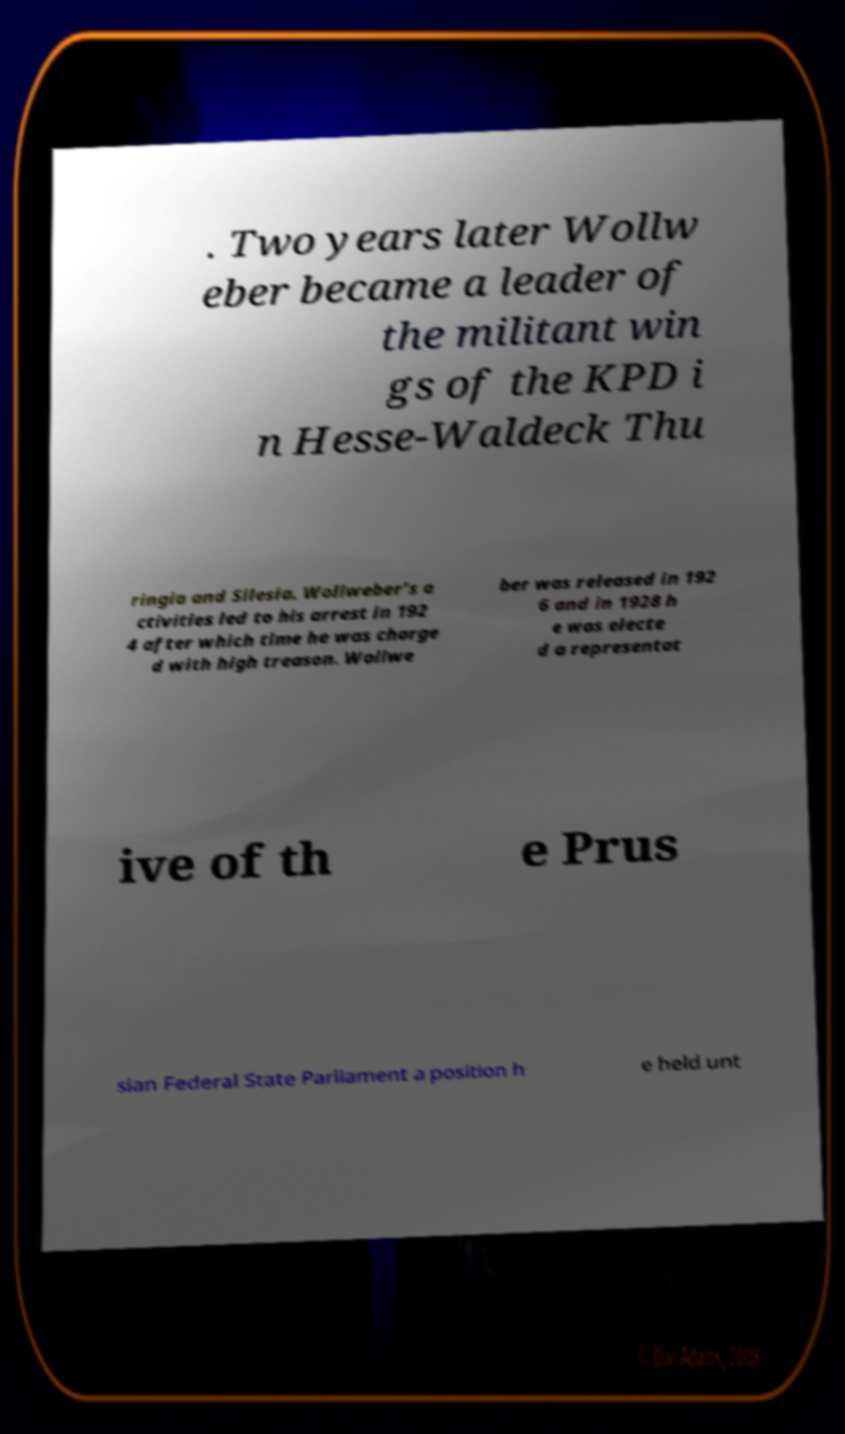Please read and relay the text visible in this image. What does it say? . Two years later Wollw eber became a leader of the militant win gs of the KPD i n Hesse-Waldeck Thu ringia and Silesia. Wollweber’s a ctivities led to his arrest in 192 4 after which time he was charge d with high treason. Wollwe ber was released in 192 6 and in 1928 h e was electe d a representat ive of th e Prus sian Federal State Parliament a position h e held unt 